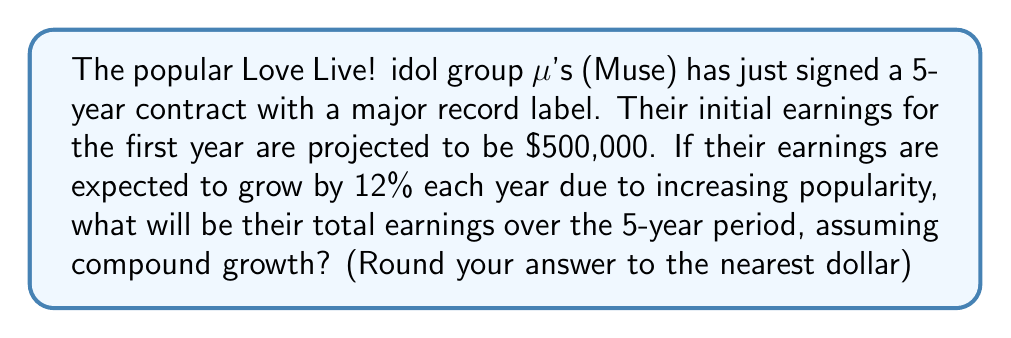What is the answer to this math problem? Let's approach this step-by-step using the compound interest formula:

1) The compound interest formula is:
   $$A = P(1 + r)^n$$
   Where:
   $A$ = Final amount
   $P$ = Principal (initial amount)
   $r$ = Annual interest rate (in decimal form)
   $n$ = Number of years

2) In this case:
   $P = 500,000$
   $r = 0.12$ (12% expressed as a decimal)
   $n = 5$ years

3) However, we need to calculate the earnings for each year and sum them up. Let's calculate year by year:

   Year 1: $500,000
   Year 2: $500,000 * (1 + 0.12)^1 = 560,000$
   Year 3: $500,000 * (1 + 0.12)^2 = 627,200$
   Year 4: $500,000 * (1 + 0.12)^3 = 702,464$
   Year 5: $500,000 * (1 + 0.12)^4 = 786,759.68$

4) Now, let's sum up all these earnings:
   $$500,000 + 560,000 + 627,200 + 702,464 + 786,759.68 = 3,176,423.68$$

5) Rounding to the nearest dollar:
   $3,176,424$
Answer: $3,176,424 